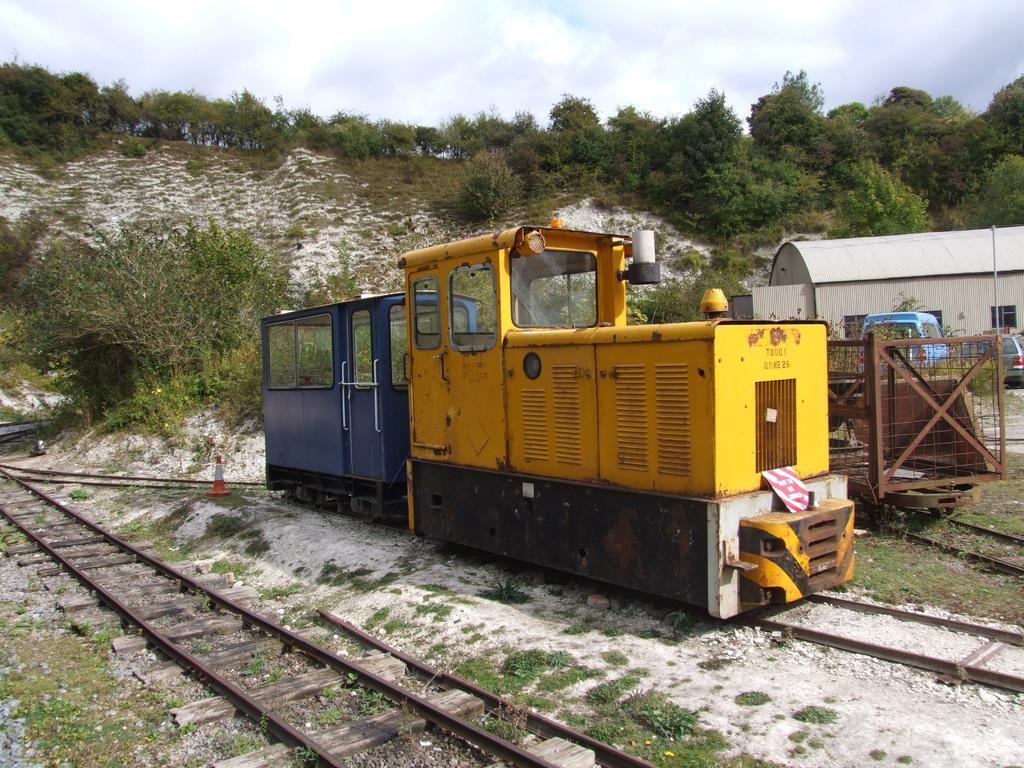In one or two sentences, can you explain what this image depicts? This is an outside view. At the bottom, I can see the railway tracks and there is a vehicle on the track which is looking like a train engine. On the right side there is a shed and two vehicles on the ground. In the background there are many trees. At the top of the image I can see the sky. 